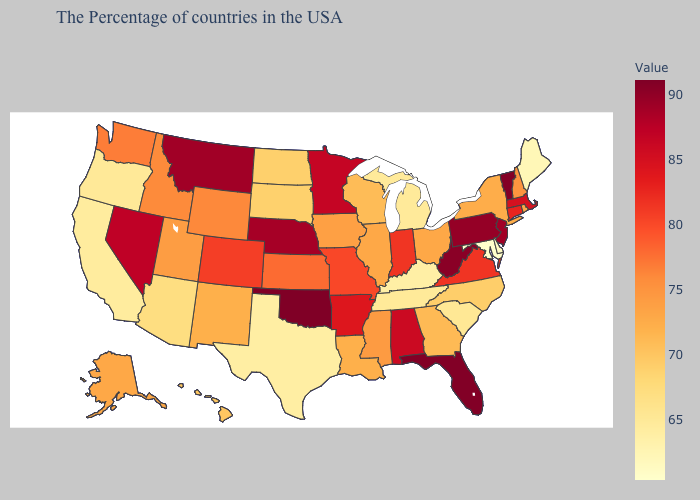Is the legend a continuous bar?
Concise answer only. Yes. Does Mississippi have a lower value than Hawaii?
Answer briefly. No. Which states have the lowest value in the USA?
Short answer required. Maryland. Which states have the lowest value in the Northeast?
Keep it brief. Maine. Which states have the highest value in the USA?
Short answer required. Oklahoma. Does Nebraska have the highest value in the MidWest?
Short answer required. Yes. Among the states that border Alabama , does Florida have the lowest value?
Answer briefly. No. 